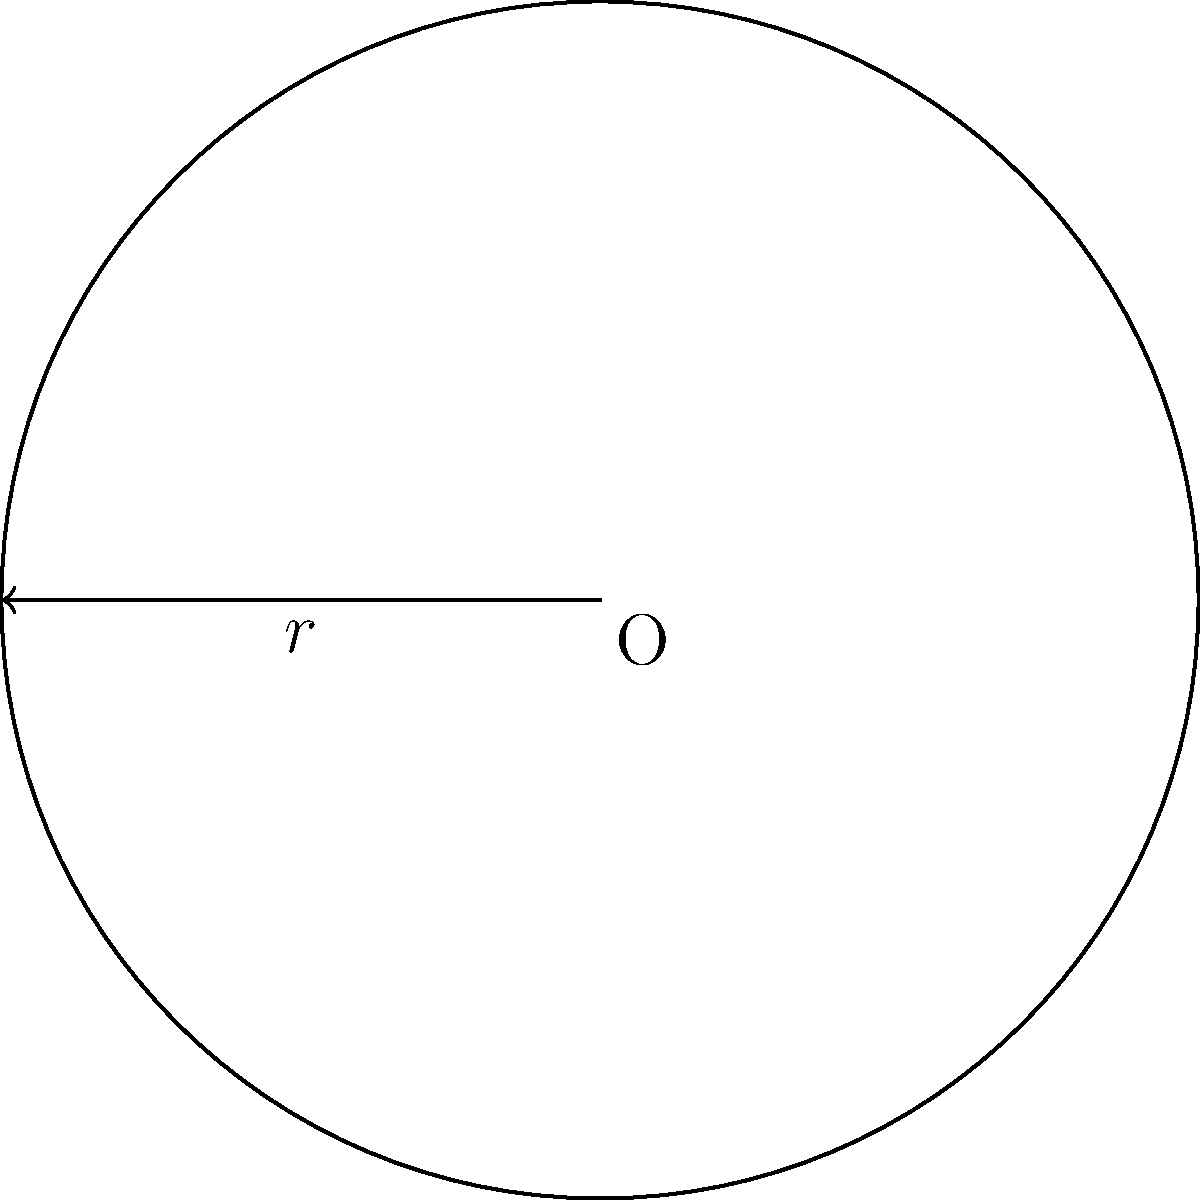As part of your aerial display routine, you need to fly in a perfect circular path. If the radius of this circular flight path is 500 meters, what is the total distance you will cover in one complete revolution? Round your answer to the nearest meter. To solve this problem, we need to calculate the circumference of the circular flight path. The formula for the circumference of a circle is:

$$C = 2\pi r$$

Where:
$C$ is the circumference (total distance of the flight path)
$\pi$ is approximately 3.14159
$r$ is the radius of the circle (500 meters)

Let's substitute the values:

$$C = 2 \times \pi \times 500$$
$$C = 2 \times 3.14159 \times 500$$
$$C = 3141.59 \text{ meters}$$

Rounding to the nearest meter:

$$C \approx 3142 \text{ meters}$$

Therefore, the total distance covered in one complete revolution of the circular flight path is approximately 3142 meters.
Answer: 3142 meters 